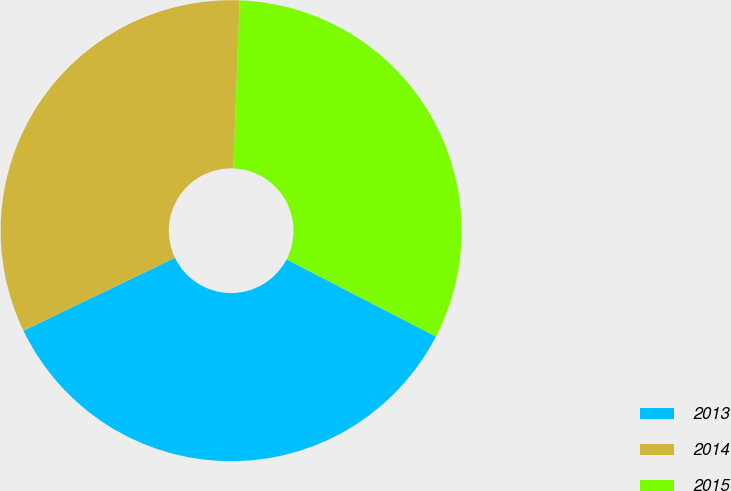Convert chart to OTSL. <chart><loc_0><loc_0><loc_500><loc_500><pie_chart><fcel>2013<fcel>2014<fcel>2015<nl><fcel>35.27%<fcel>32.72%<fcel>32.01%<nl></chart> 